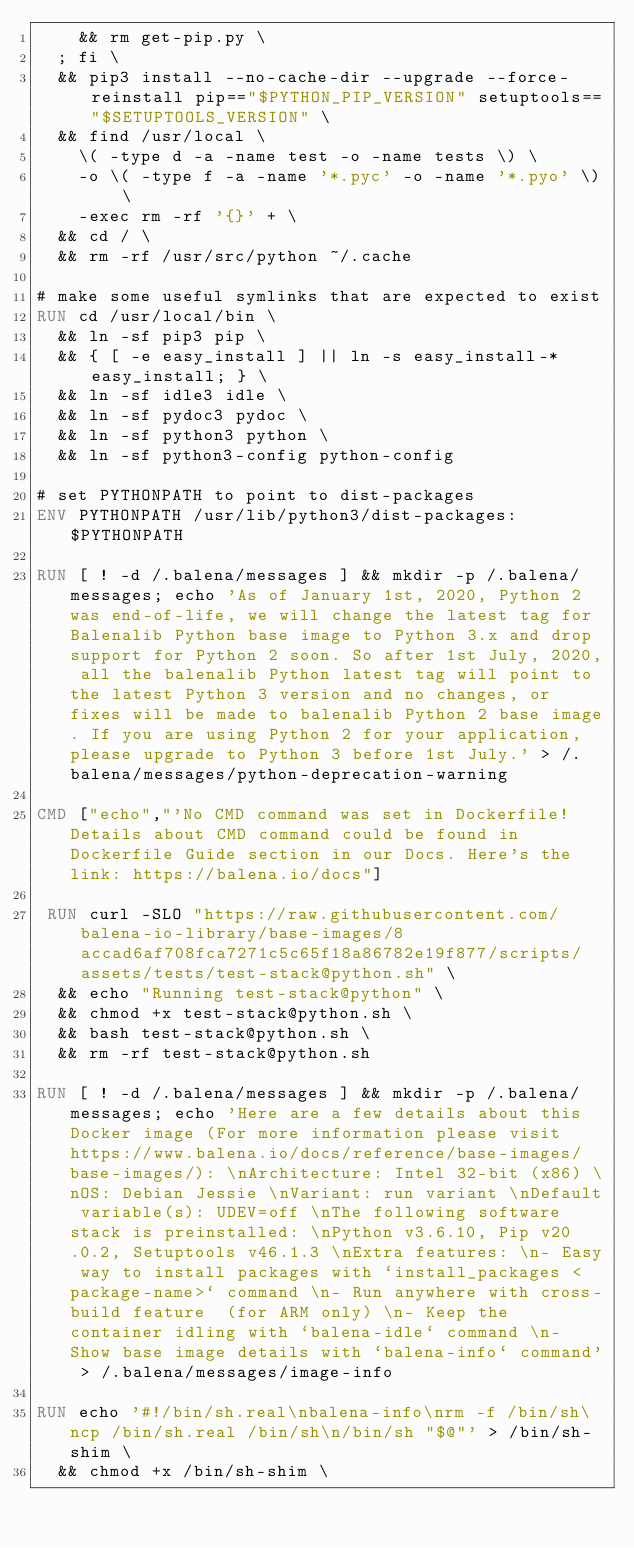<code> <loc_0><loc_0><loc_500><loc_500><_Dockerfile_>		&& rm get-pip.py \
	; fi \
	&& pip3 install --no-cache-dir --upgrade --force-reinstall pip=="$PYTHON_PIP_VERSION" setuptools=="$SETUPTOOLS_VERSION" \
	&& find /usr/local \
		\( -type d -a -name test -o -name tests \) \
		-o \( -type f -a -name '*.pyc' -o -name '*.pyo' \) \
		-exec rm -rf '{}' + \
	&& cd / \
	&& rm -rf /usr/src/python ~/.cache

# make some useful symlinks that are expected to exist
RUN cd /usr/local/bin \
	&& ln -sf pip3 pip \
	&& { [ -e easy_install ] || ln -s easy_install-* easy_install; } \
	&& ln -sf idle3 idle \
	&& ln -sf pydoc3 pydoc \
	&& ln -sf python3 python \
	&& ln -sf python3-config python-config

# set PYTHONPATH to point to dist-packages
ENV PYTHONPATH /usr/lib/python3/dist-packages:$PYTHONPATH

RUN [ ! -d /.balena/messages ] && mkdir -p /.balena/messages; echo 'As of January 1st, 2020, Python 2 was end-of-life, we will change the latest tag for Balenalib Python base image to Python 3.x and drop support for Python 2 soon. So after 1st July, 2020, all the balenalib Python latest tag will point to the latest Python 3 version and no changes, or fixes will be made to balenalib Python 2 base image. If you are using Python 2 for your application, please upgrade to Python 3 before 1st July.' > /.balena/messages/python-deprecation-warning

CMD ["echo","'No CMD command was set in Dockerfile! Details about CMD command could be found in Dockerfile Guide section in our Docs. Here's the link: https://balena.io/docs"]

 RUN curl -SLO "https://raw.githubusercontent.com/balena-io-library/base-images/8accad6af708fca7271c5c65f18a86782e19f877/scripts/assets/tests/test-stack@python.sh" \
  && echo "Running test-stack@python" \
  && chmod +x test-stack@python.sh \
  && bash test-stack@python.sh \
  && rm -rf test-stack@python.sh 

RUN [ ! -d /.balena/messages ] && mkdir -p /.balena/messages; echo 'Here are a few details about this Docker image (For more information please visit https://www.balena.io/docs/reference/base-images/base-images/): \nArchitecture: Intel 32-bit (x86) \nOS: Debian Jessie \nVariant: run variant \nDefault variable(s): UDEV=off \nThe following software stack is preinstalled: \nPython v3.6.10, Pip v20.0.2, Setuptools v46.1.3 \nExtra features: \n- Easy way to install packages with `install_packages <package-name>` command \n- Run anywhere with cross-build feature  (for ARM only) \n- Keep the container idling with `balena-idle` command \n- Show base image details with `balena-info` command' > /.balena/messages/image-info

RUN echo '#!/bin/sh.real\nbalena-info\nrm -f /bin/sh\ncp /bin/sh.real /bin/sh\n/bin/sh "$@"' > /bin/sh-shim \
	&& chmod +x /bin/sh-shim \</code> 